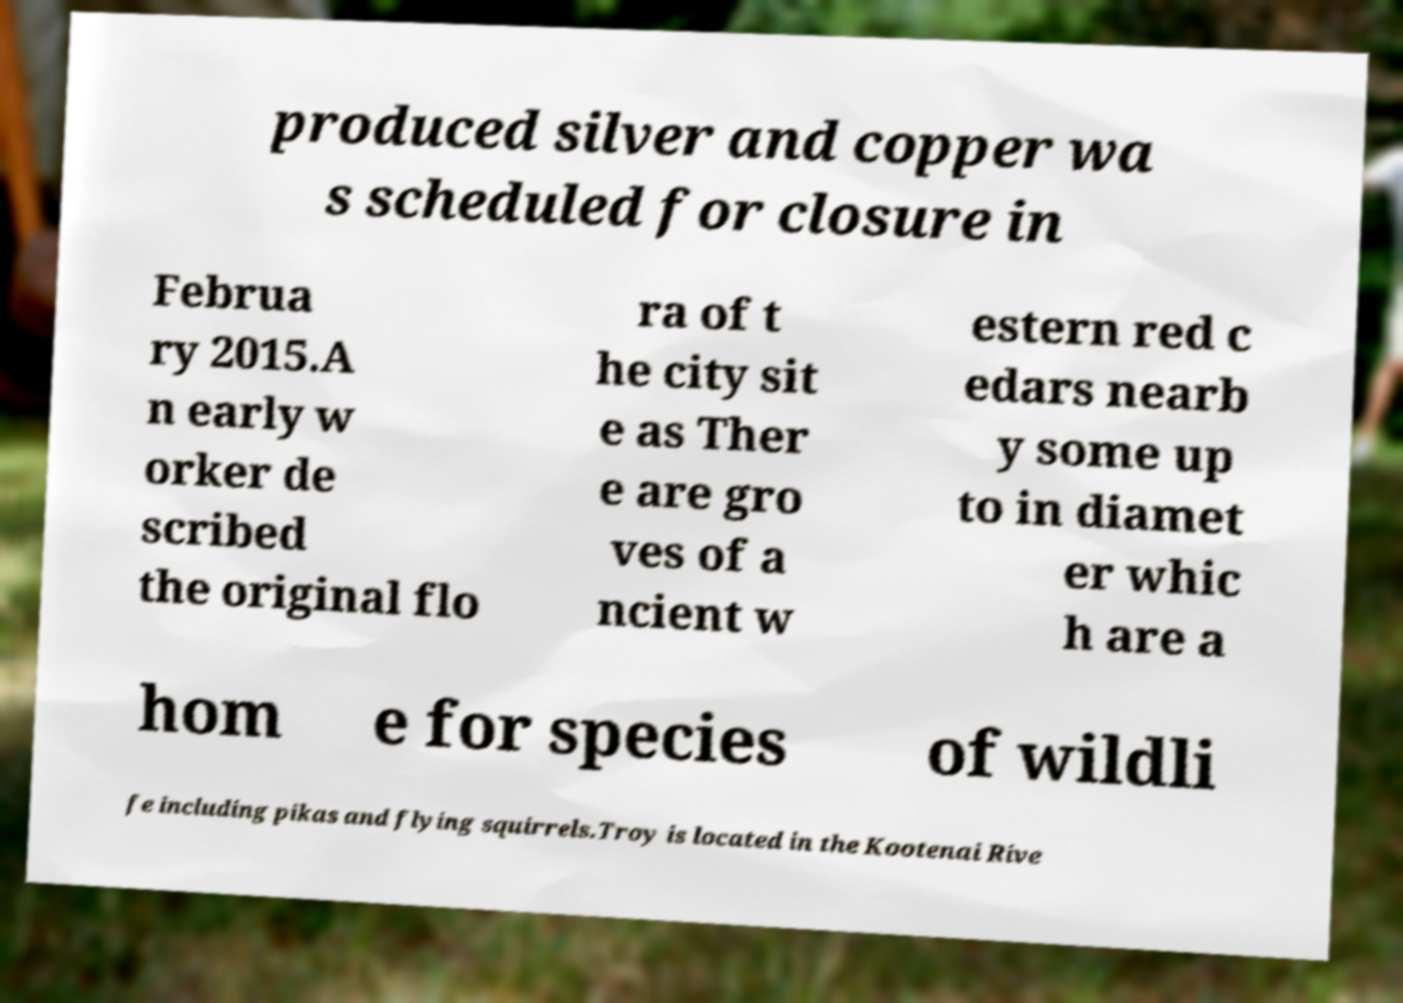Can you accurately transcribe the text from the provided image for me? produced silver and copper wa s scheduled for closure in Februa ry 2015.A n early w orker de scribed the original flo ra of t he city sit e as Ther e are gro ves of a ncient w estern red c edars nearb y some up to in diamet er whic h are a hom e for species of wildli fe including pikas and flying squirrels.Troy is located in the Kootenai Rive 